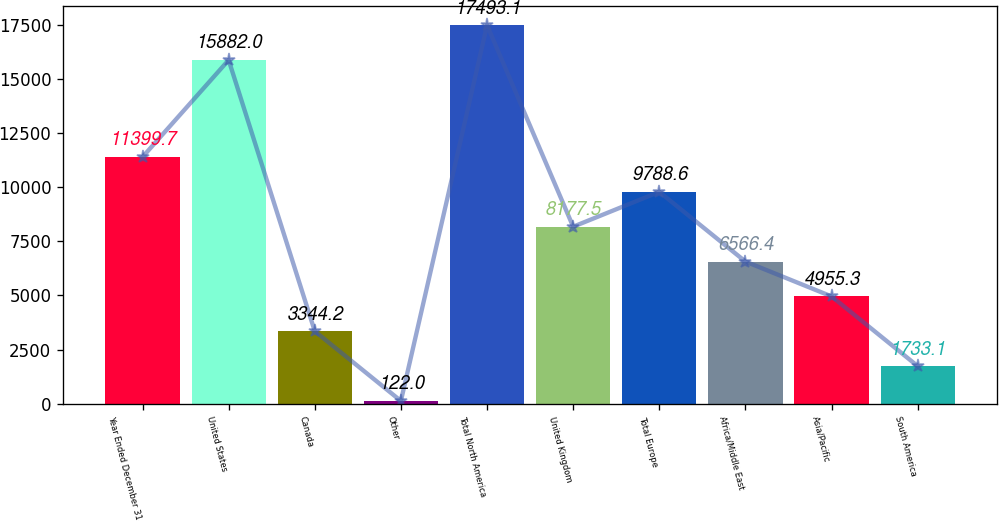Convert chart to OTSL. <chart><loc_0><loc_0><loc_500><loc_500><bar_chart><fcel>Year Ended December 31<fcel>United States<fcel>Canada<fcel>Other<fcel>Total North America<fcel>United Kingdom<fcel>Total Europe<fcel>Africa/Middle East<fcel>Asia/Pacific<fcel>South America<nl><fcel>11399.7<fcel>15882<fcel>3344.2<fcel>122<fcel>17493.1<fcel>8177.5<fcel>9788.6<fcel>6566.4<fcel>4955.3<fcel>1733.1<nl></chart> 